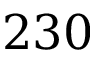Convert formula to latex. <formula><loc_0><loc_0><loc_500><loc_500>2 3 0</formula> 